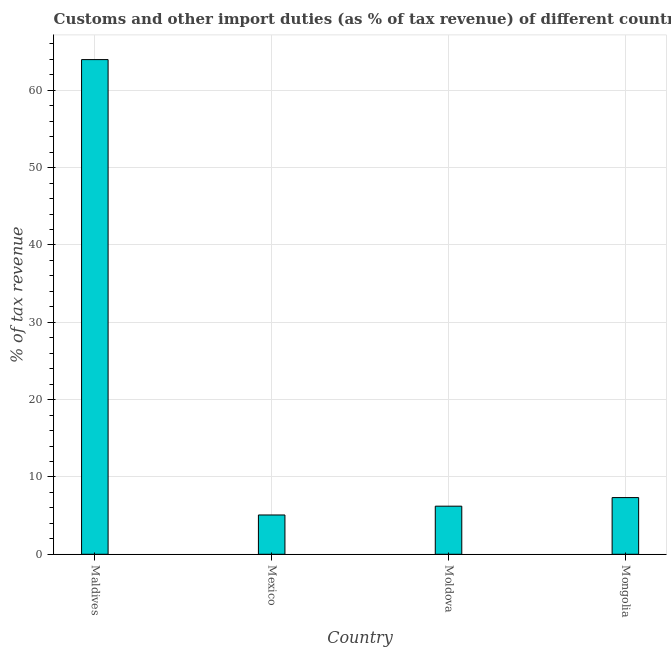What is the title of the graph?
Your answer should be compact. Customs and other import duties (as % of tax revenue) of different countries in 1997. What is the label or title of the X-axis?
Your response must be concise. Country. What is the label or title of the Y-axis?
Your answer should be very brief. % of tax revenue. What is the customs and other import duties in Maldives?
Give a very brief answer. 63.97. Across all countries, what is the maximum customs and other import duties?
Offer a very short reply. 63.97. Across all countries, what is the minimum customs and other import duties?
Offer a very short reply. 5.08. In which country was the customs and other import duties maximum?
Make the answer very short. Maldives. What is the sum of the customs and other import duties?
Your answer should be compact. 82.61. What is the difference between the customs and other import duties in Maldives and Mongolia?
Keep it short and to the point. 56.64. What is the average customs and other import duties per country?
Your answer should be compact. 20.65. What is the median customs and other import duties?
Offer a very short reply. 6.78. What is the ratio of the customs and other import duties in Maldives to that in Mexico?
Make the answer very short. 12.59. Is the customs and other import duties in Maldives less than that in Mongolia?
Offer a very short reply. No. Is the difference between the customs and other import duties in Moldova and Mongolia greater than the difference between any two countries?
Offer a terse response. No. What is the difference between the highest and the second highest customs and other import duties?
Keep it short and to the point. 56.64. Is the sum of the customs and other import duties in Moldova and Mongolia greater than the maximum customs and other import duties across all countries?
Your response must be concise. No. What is the difference between the highest and the lowest customs and other import duties?
Your response must be concise. 58.89. In how many countries, is the customs and other import duties greater than the average customs and other import duties taken over all countries?
Your answer should be very brief. 1. How many countries are there in the graph?
Make the answer very short. 4. What is the difference between two consecutive major ticks on the Y-axis?
Keep it short and to the point. 10. What is the % of tax revenue of Maldives?
Make the answer very short. 63.97. What is the % of tax revenue in Mexico?
Keep it short and to the point. 5.08. What is the % of tax revenue of Moldova?
Provide a succinct answer. 6.22. What is the % of tax revenue of Mongolia?
Offer a very short reply. 7.33. What is the difference between the % of tax revenue in Maldives and Mexico?
Provide a succinct answer. 58.89. What is the difference between the % of tax revenue in Maldives and Moldova?
Give a very brief answer. 57.75. What is the difference between the % of tax revenue in Maldives and Mongolia?
Your response must be concise. 56.64. What is the difference between the % of tax revenue in Mexico and Moldova?
Your response must be concise. -1.14. What is the difference between the % of tax revenue in Mexico and Mongolia?
Your response must be concise. -2.25. What is the difference between the % of tax revenue in Moldova and Mongolia?
Give a very brief answer. -1.11. What is the ratio of the % of tax revenue in Maldives to that in Mexico?
Keep it short and to the point. 12.59. What is the ratio of the % of tax revenue in Maldives to that in Moldova?
Make the answer very short. 10.29. What is the ratio of the % of tax revenue in Maldives to that in Mongolia?
Offer a very short reply. 8.72. What is the ratio of the % of tax revenue in Mexico to that in Moldova?
Give a very brief answer. 0.82. What is the ratio of the % of tax revenue in Mexico to that in Mongolia?
Provide a succinct answer. 0.69. What is the ratio of the % of tax revenue in Moldova to that in Mongolia?
Your response must be concise. 0.85. 